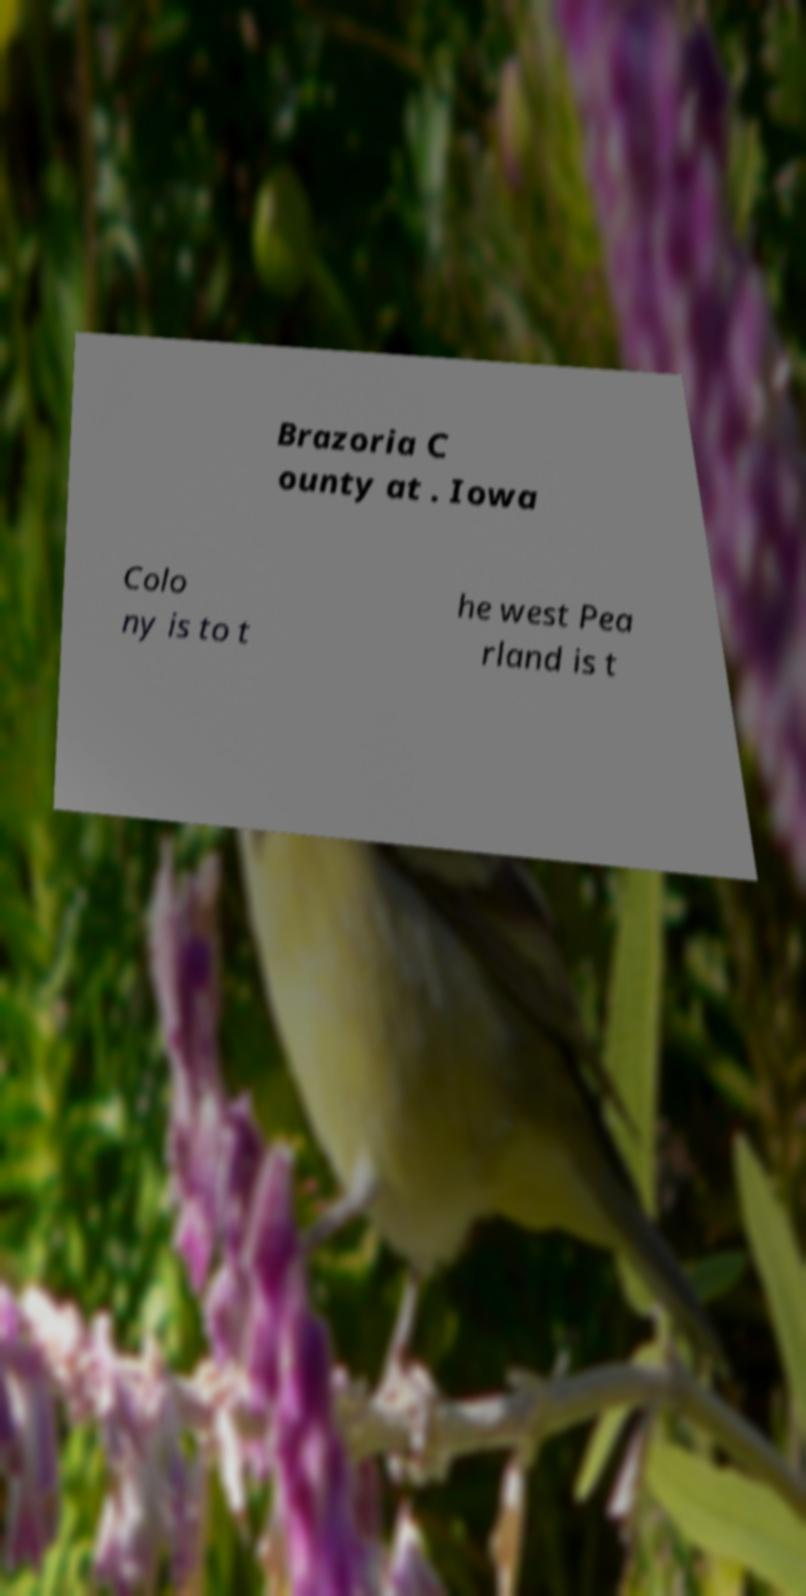For documentation purposes, I need the text within this image transcribed. Could you provide that? Brazoria C ounty at . Iowa Colo ny is to t he west Pea rland is t 